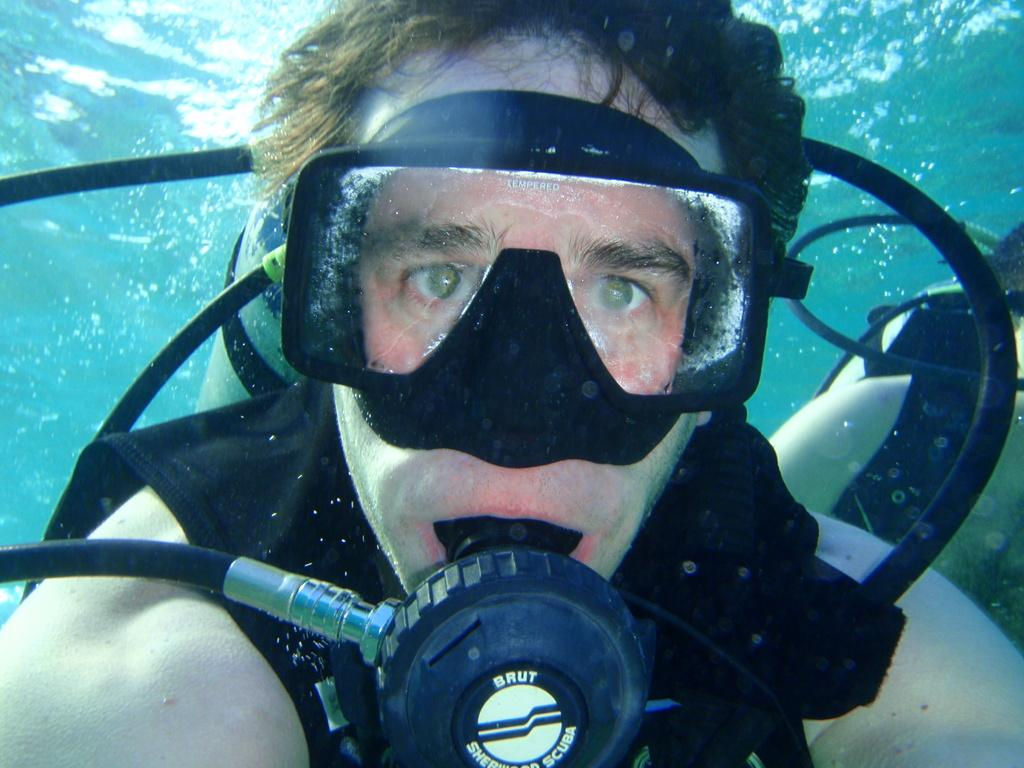What is the man in the image wearing on his face? The man is wearing a mask in the image. What is the man doing with the oxygen cylinder? The man is using an oxygen cylinder in the water. Can you describe the person on the right side of the image? There is another person on the right side of the image. What type of competition is taking place in the image? There is no competition present in the image. What is the roof made of in the image? There is no roof present in the image. 